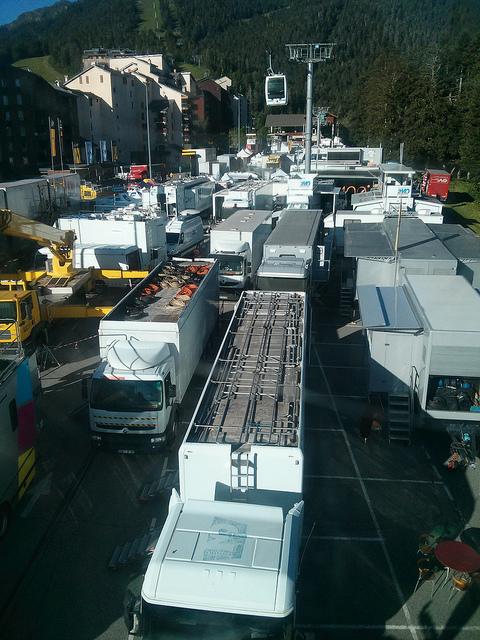Are there any open containers in the picture?
Write a very short answer. Yes. How many steps are on the first set of stairs?
Concise answer only. 6. This photo shows a behind the scenes look of what industry?
Answer briefly. Trucking. 